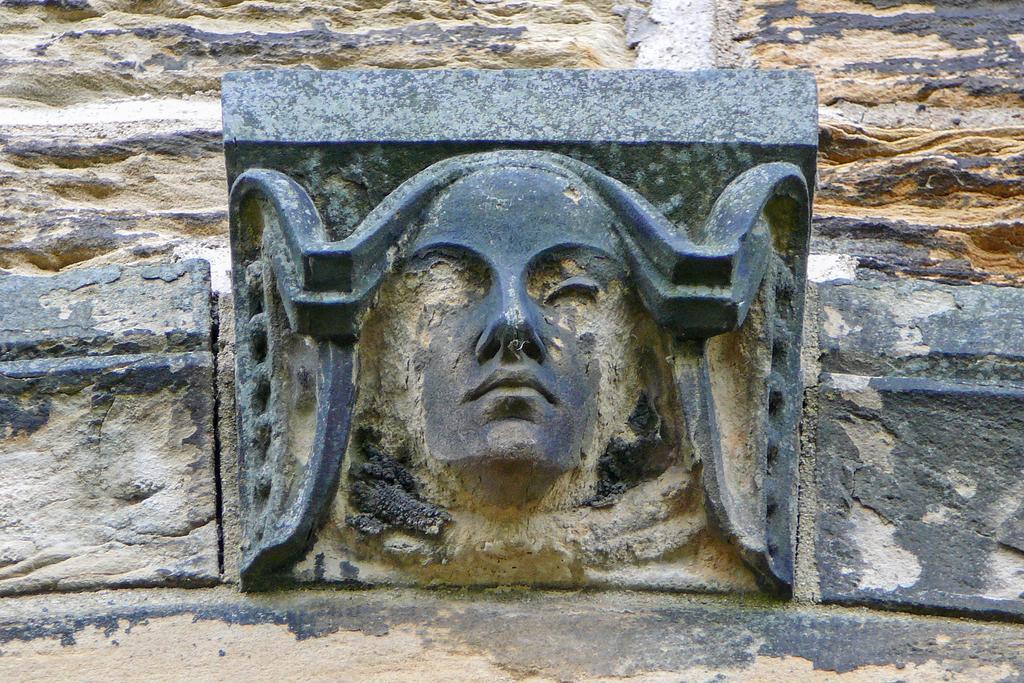In one or two sentences, can you explain what this image depicts? It's a statue of a human shaped. 